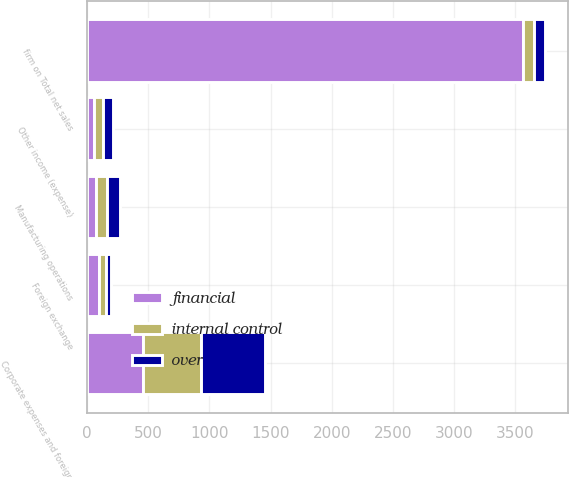Convert chart. <chart><loc_0><loc_0><loc_500><loc_500><stacked_bar_chart><ecel><fcel>firm on Total net sales<fcel>Foreign exchange<fcel>Manufacturing operations<fcel>Corporate expenses and foreign<fcel>Other income (expense)<nl><fcel>internal control<fcel>89<fcel>64<fcel>89<fcel>476<fcel>77<nl><fcel>over<fcel>89<fcel>39<fcel>113<fcel>522<fcel>80<nl><fcel>financial<fcel>3569<fcel>93<fcel>69<fcel>455<fcel>54<nl></chart> 